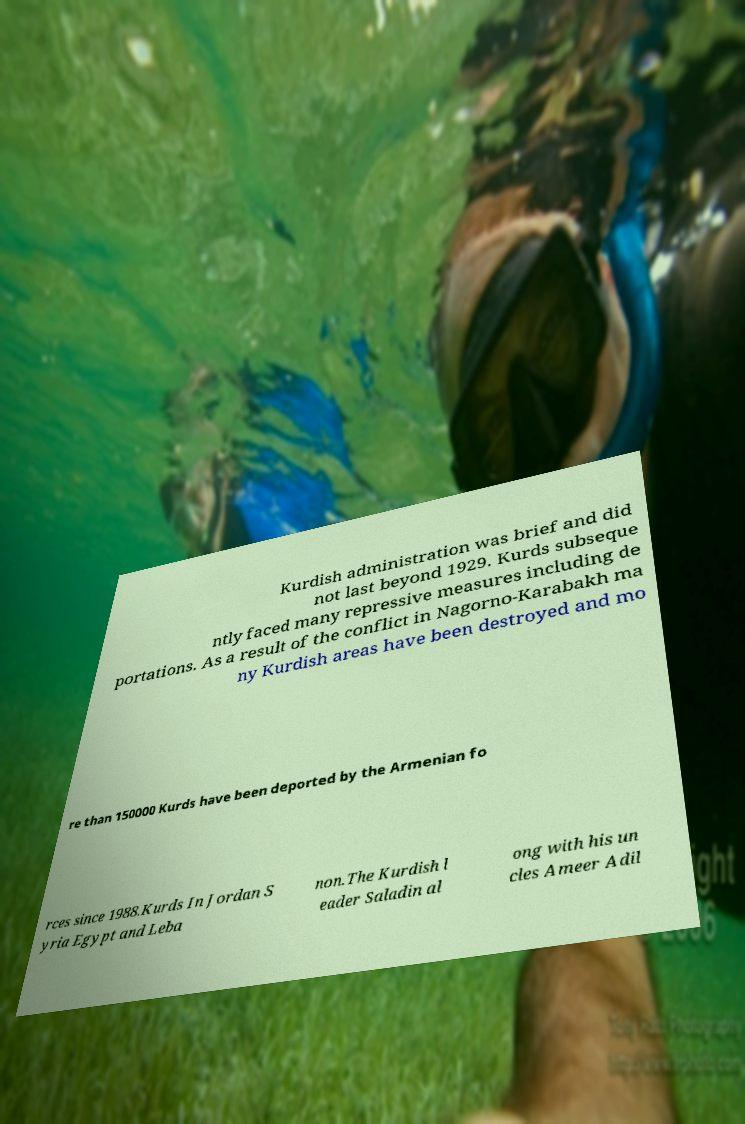For documentation purposes, I need the text within this image transcribed. Could you provide that? Kurdish administration was brief and did not last beyond 1929. Kurds subseque ntly faced many repressive measures including de portations. As a result of the conflict in Nagorno-Karabakh ma ny Kurdish areas have been destroyed and mo re than 150000 Kurds have been deported by the Armenian fo rces since 1988.Kurds In Jordan S yria Egypt and Leba non.The Kurdish l eader Saladin al ong with his un cles Ameer Adil 